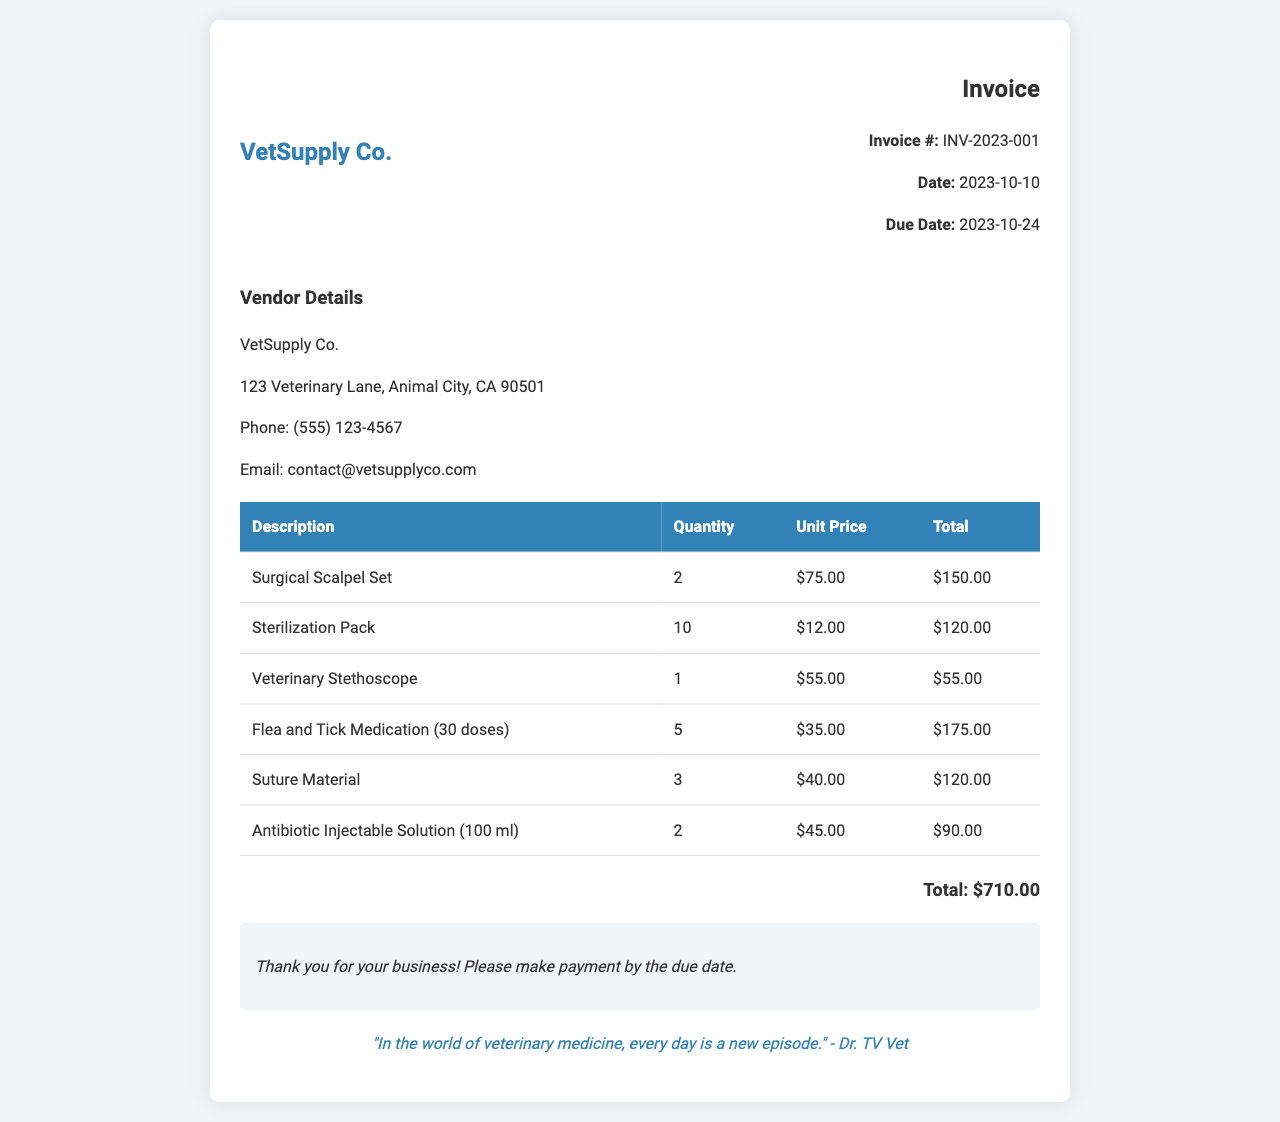What is the invoice number? The invoice number is clearly listed under the invoice details section, which is INV-2023-001.
Answer: INV-2023-001 What is the total cost of the invoice? The total cost is found at the bottom of the invoice, which indicates a total of $710.00.
Answer: $710.00 How many surgical scalpel sets were purchased? The quantity of surgical scalpel sets is specified in the table as 2.
Answer: 2 Who is the vendor for this invoice? The vendor details are prominently displayed at the top of the invoice, indicating VetSupply Co.
Answer: VetSupply Co What is the due date for the payment? The due date is provided in the invoice details, showing that the payment is due on 2023-10-24.
Answer: 2023-10-24 What is the unit price of the Flea and Tick Medication? The unit price for Flea and Tick Medication is listed as $35.00 in the table.
Answer: $35.00 How many different surgical tools are listed in the invoice? By examining the table, there are 6 different surgical tools and supplies listed.
Answer: 6 What is the email contact for the vendor? The vendor's email is given in the vendor details section, which is contact@vetsupplyco.com.
Answer: contact@vetsupplyco.com What special note is included in the invoice? The special note thanks the customer and instructs them to make payment by the due date.
Answer: Thank you for your business! Please make payment by the due date 